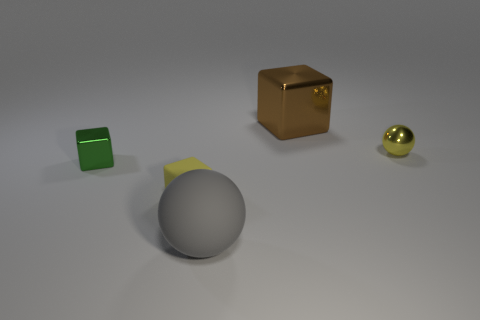Add 3 small red cylinders. How many objects exist? 8 Subtract all cubes. How many objects are left? 2 Subtract 1 yellow cubes. How many objects are left? 4 Subtract all tiny blue matte balls. Subtract all tiny objects. How many objects are left? 2 Add 4 rubber things. How many rubber things are left? 6 Add 1 big gray balls. How many big gray balls exist? 2 